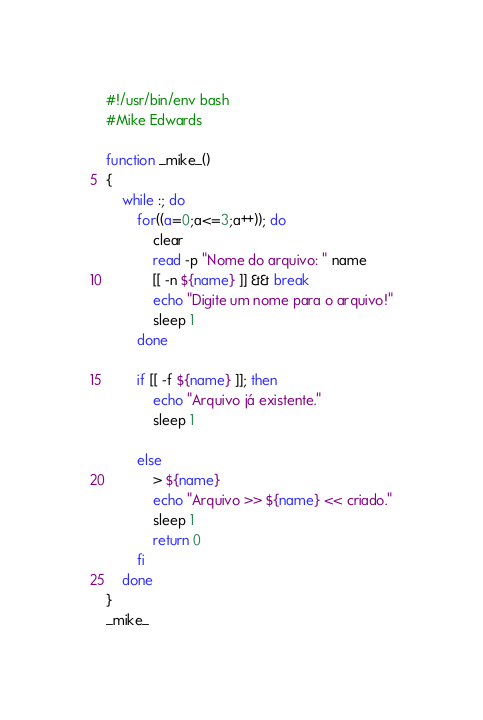<code> <loc_0><loc_0><loc_500><loc_500><_Bash_>#!/usr/bin/env bash
#Mike Edwards

function _mike_()
{
    while :; do
        for((a=0;a<=3;a++)); do
            clear
            read -p "Nome do arquivo: " name
            [[ -n ${name} ]] && break
            echo "Digite um nome para o arquivo!"
            sleep 1
        done

        if [[ -f ${name} ]]; then
            echo "Arquivo já existente."
            sleep 1

        else
            > ${name}
            echo "Arquivo >> ${name} << criado."
            sleep 1
            return 0
        fi
    done
}
_mike_
</code> 